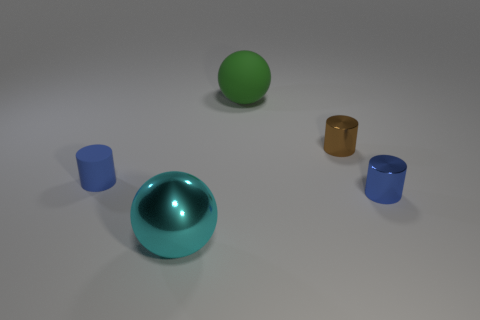Add 2 tiny brown cubes. How many objects exist? 7 Subtract all cylinders. How many objects are left? 2 Subtract 0 green cylinders. How many objects are left? 5 Subtract all big green things. Subtract all big spheres. How many objects are left? 2 Add 4 big green things. How many big green things are left? 5 Add 1 spheres. How many spheres exist? 3 